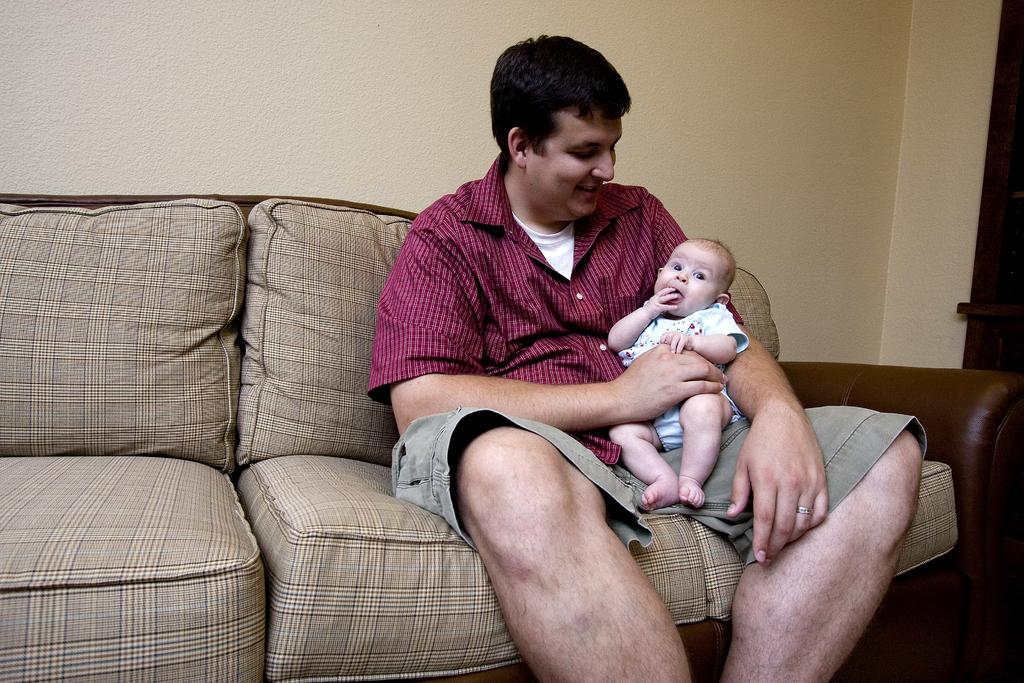What is the person in the image doing? The person is holding a baby in the image. Where is the person sitting? The person is sitting on a sofa. What can be seen in the background of the image? There is a wall in the background of the image. What type of owl can be seen in the image? There is no owl present in the image. What is the acoustics like in the room where the image was taken? The image does not provide information about the acoustics of the room. 